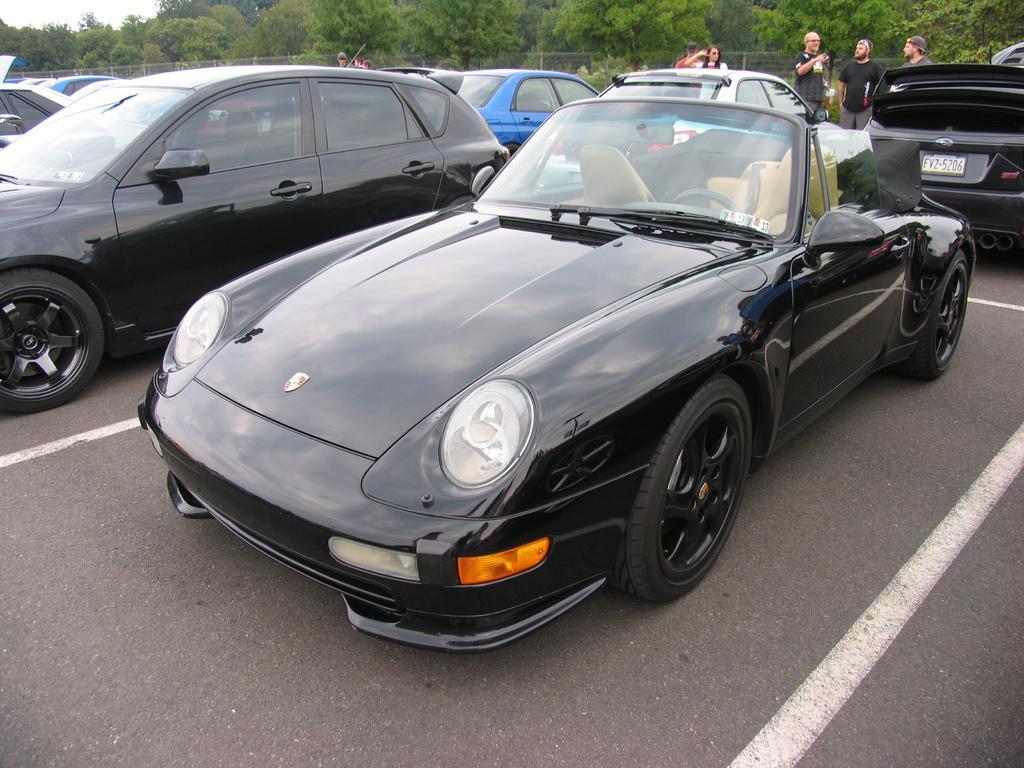How would you summarize this image in a sentence or two? In this image we can see different models of the cars on the road, there are few people behind the cars, and at the top of the image we can see few trees. 